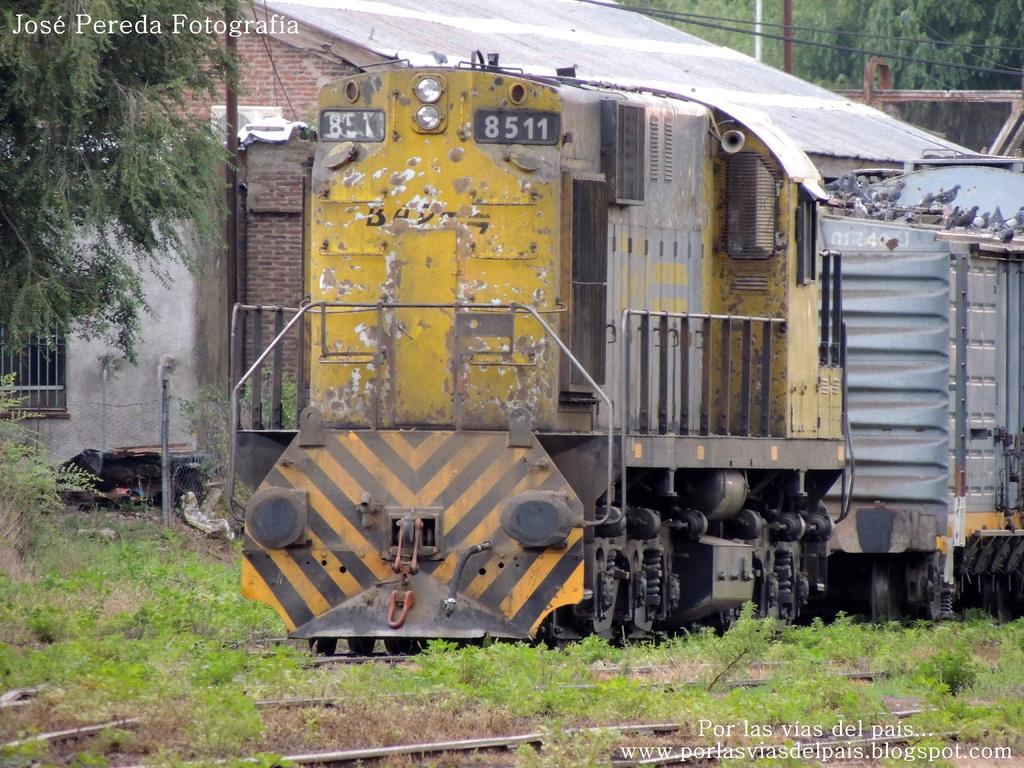Can you describe this image briefly? There is a train in the foreground area of the image and grassland at the bottom side, there are trees, poles and the sky in the background. There is text at the top side. 